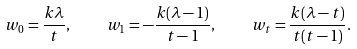<formula> <loc_0><loc_0><loc_500><loc_500>w _ { 0 } = \frac { k \lambda } { t } , \quad w _ { 1 } = - \frac { k ( \lambda - 1 ) } { t - 1 } , \quad w _ { t } = \frac { k ( \lambda - t ) } { t ( t - 1 ) } .</formula> 